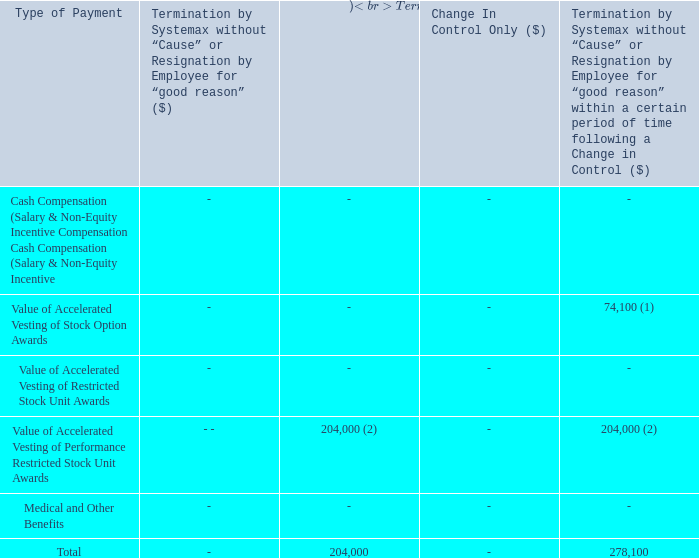Manoj Shetty
(1) Represents accelerated vesting of 20,687 stock options. Pursuant to Mr. Shetty's stock option agreement (January 17, 2019), if Mr.
Shetty’s employment is terminated without cause or for good reason within six months following a “change in control”, he will become
immediately vested in all outstanding unvested stock options, and all of Mr. Shetty’s outstanding options shall remain exercisable in
accordance with their terms, but in no event for less than 90 days after such termination
(2) Represents accelerated vesting of 8,107 unvested performance restricted stock units. Pursuant to Mr. Shetty's performance restricted
stock unit agreement (dated January 17, 2019), if Mr. Shetty’s employment is terminated without cause or for good reason within six
months following a “change in control” or if Mr. Shetty's employment is terminated due to death or total disability, all non-vested units
shall accelerate and be vested as of the date of termination.
What are Manoj Shetty's respective accelerated vesting of stock options and unvested performance restricted stock units respectively? 20,687, 8,107. What is Manoj Shetty's total payment as a result of termination due to death or total disability? 204,000. What is Manoj Shetty's total payment due to termination by Systemax without "cause" or resignation for "good reason" within a certain period of time following a change in control? 278,100. What is Manoj Shetty's total accelerated vesting of stock options and unvested performance restricted stock units? 20,687 + 8,107 
Answer: 28794. What is the value of stock option awards as a percentage of the total payment for termination by Systemax without “Cause” within a certain period of time following a change in control?
Answer scale should be: percent. 74,100/278,100 
Answer: 26.65. What is the total payment due to Manoj Shetty from all sources? 278,100+ 204,000 
Answer: 482100. 